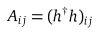Convert formula to latex. <formula><loc_0><loc_0><loc_500><loc_500>A _ { i j } = ( h ^ { \dagger } h ) _ { i j }</formula> 